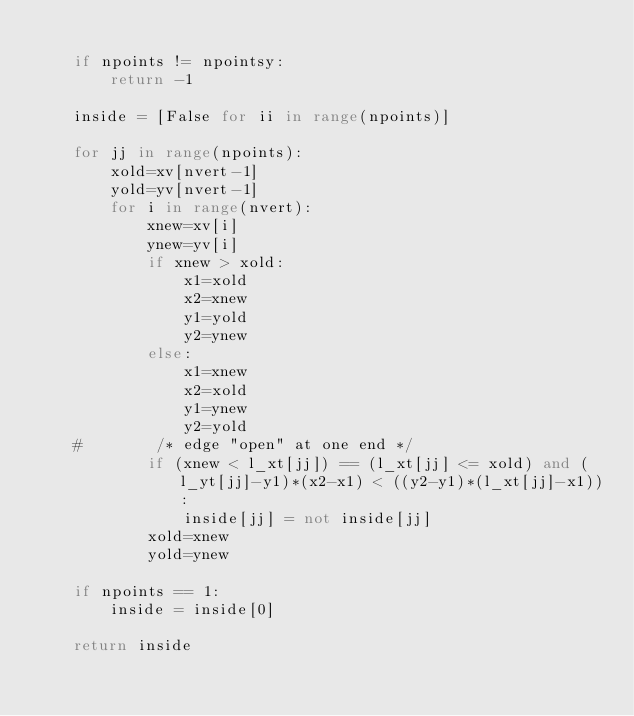<code> <loc_0><loc_0><loc_500><loc_500><_Python_>
    if npoints != npointsy:
        return -1

    inside = [False for ii in range(npoints)]

    for jj in range(npoints):
        xold=xv[nvert-1]
        yold=yv[nvert-1]
        for i in range(nvert):
            xnew=xv[i]
            ynew=yv[i]
            if xnew > xold:
                x1=xold
                x2=xnew
                y1=yold
                y2=ynew
            else:
                x1=xnew
                x2=xold
                y1=ynew
                y2=yold
    #        /* edge "open" at one end */
            if (xnew < l_xt[jj]) == (l_xt[jj] <= xold) and (l_yt[jj]-y1)*(x2-x1) < ((y2-y1)*(l_xt[jj]-x1)):
                inside[jj] = not inside[jj]
            xold=xnew
            yold=ynew

    if npoints == 1:
        inside = inside[0]

    return inside 
 
</code> 